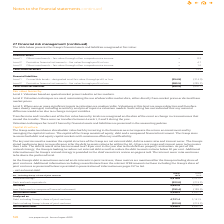According to Intu Properties's financial document, What is the total borrowings in 2019? According to the financial document, 4,916.8 (in millions). The relevant text states: "Total borrowings 4,916.8 5,331.0..." Also, What is the total borrowings in 2018? According to the financial document, 5,331.0 (in millions). The relevant text states: "Total borrowings 4,916.8 5,331.0..." Also, What is the Net debt in 2019? According to the financial document, 4,693.8 (in millions). The relevant text states: "Net debt 4,693.8 5,056.7..." Also, can you calculate: What is the percentage change in the net debt from 2018 to 2019? To answer this question, I need to perform calculations using the financial data. The calculation is: (4,693.8-5,056.7)/5,056.7, which equals -7.18 (percentage). This is based on the information: "Net debt 4,693.8 5,056.7 Net debt 4,693.8 5,056.7..." The key data points involved are: 4,693.8, 5,056.7. Also, can you calculate: What is the percentage change in the net external debt from 2018 to 2019? To answer this question, I need to perform calculations using the financial data. The calculation is: (4,498.4-4,867.2)/ 4,867.2, which equals -7.58 (percentage). This is based on the information: "Net external debt 4,498.4 4,867.2 Net external debt 4,498.4 4,867.2..." The key data points involved are: 4,498.4, 4,867.2. Also, can you calculate: What is the percentage of total borrowings in net debt in 2019? Based on the calculation: 4,916.8/4,693.8, the result is 104.75 (percentage). This is based on the information: "Net debt 4,693.8 5,056.7 Total borrowings 4,916.8 5,331.0..." The key data points involved are: 4,693.8, 4,916.8. 